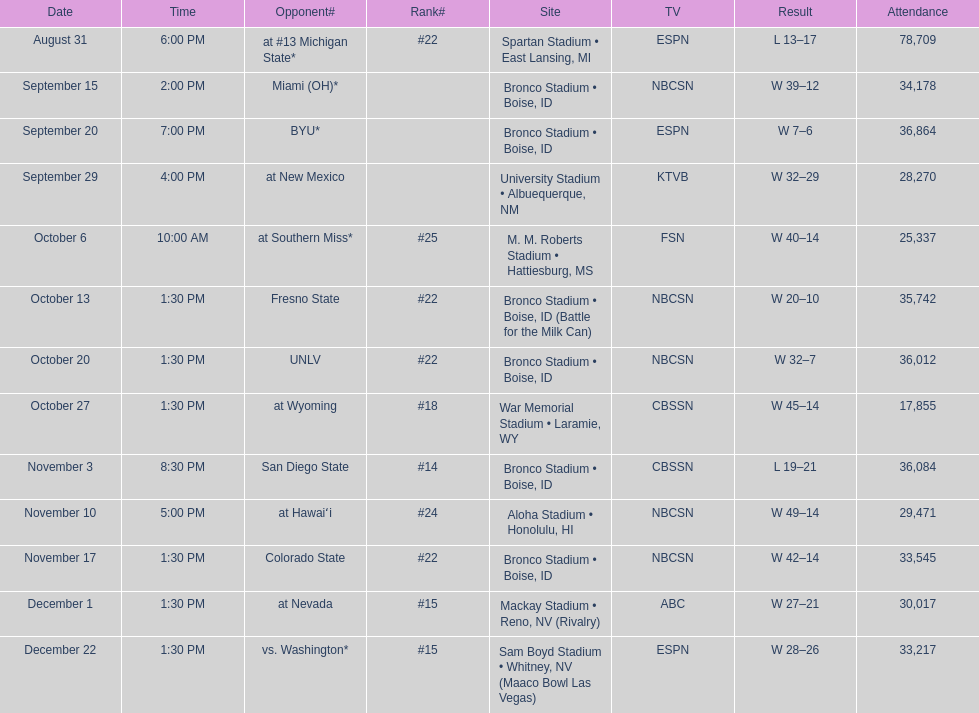Opponent broncos faced next after unlv Wyoming. 